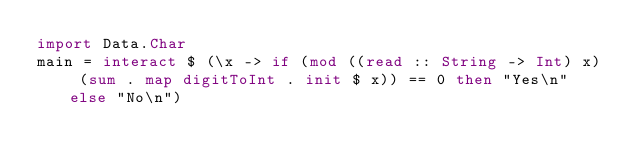Convert code to text. <code><loc_0><loc_0><loc_500><loc_500><_Haskell_>import Data.Char
main = interact $ (\x -> if (mod ((read :: String -> Int) x) (sum . map digitToInt . init $ x)) == 0 then "Yes\n" else "No\n")
</code> 